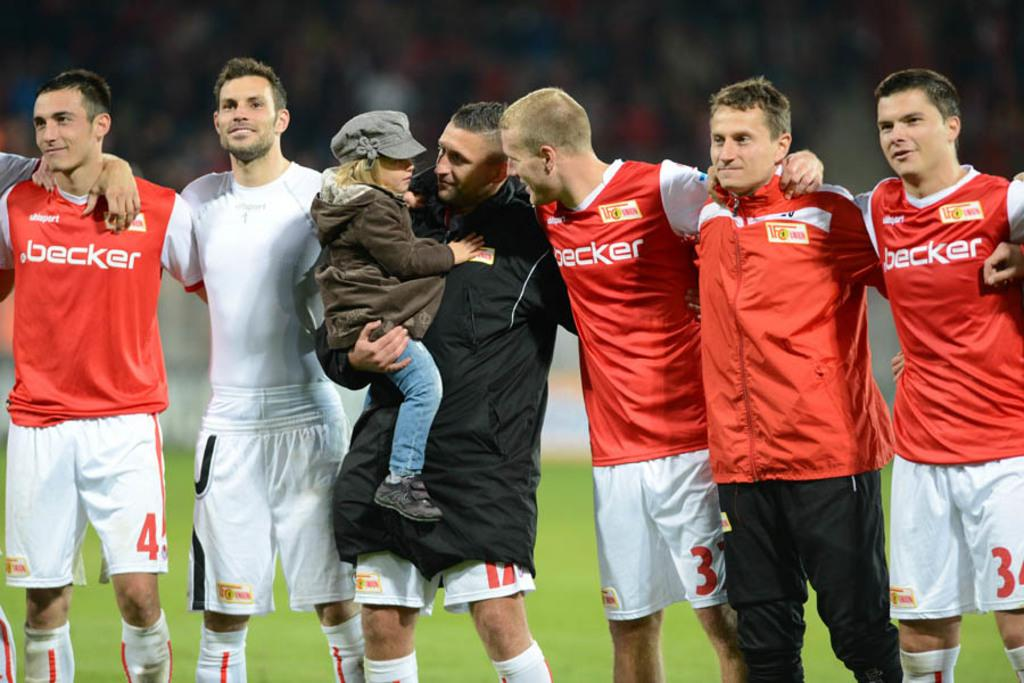What is the main subject of the image? The main subject of the image is a group of people standing. Can you describe any specific actions or interactions among the people? Yes, a man is carrying a baby in the image. What is the condition of the background in the image? The background of the image is blurred. What type of dress are the fairies wearing in the image? There are no fairies present in the image, so it is not possible to determine what type of dress they might be wearing. 